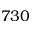Convert formula to latex. <formula><loc_0><loc_0><loc_500><loc_500>7 3 0</formula> 